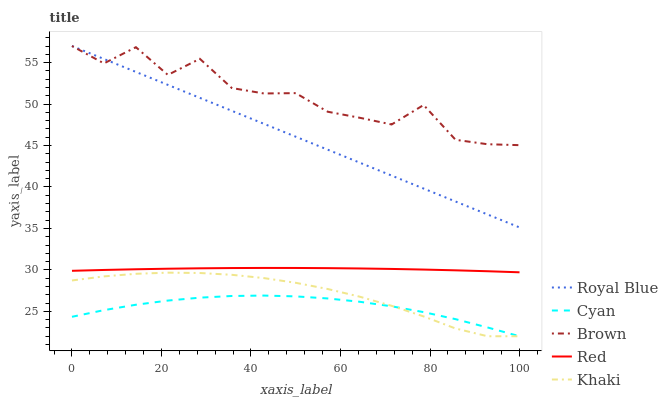Does Khaki have the minimum area under the curve?
Answer yes or no. No. Does Khaki have the maximum area under the curve?
Answer yes or no. No. Is Khaki the smoothest?
Answer yes or no. No. Is Khaki the roughest?
Answer yes or no. No. Does Brown have the lowest value?
Answer yes or no. No. Does Khaki have the highest value?
Answer yes or no. No. Is Cyan less than Royal Blue?
Answer yes or no. Yes. Is Brown greater than Khaki?
Answer yes or no. Yes. Does Cyan intersect Royal Blue?
Answer yes or no. No. 